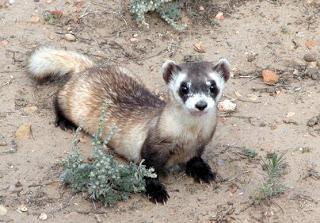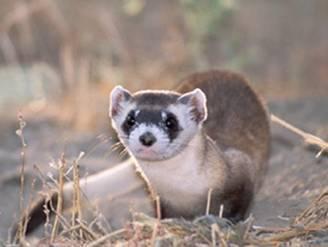The first image is the image on the left, the second image is the image on the right. Considering the images on both sides, is "One of the animals stands at the entrance to a hole." valid? Answer yes or no. No. 